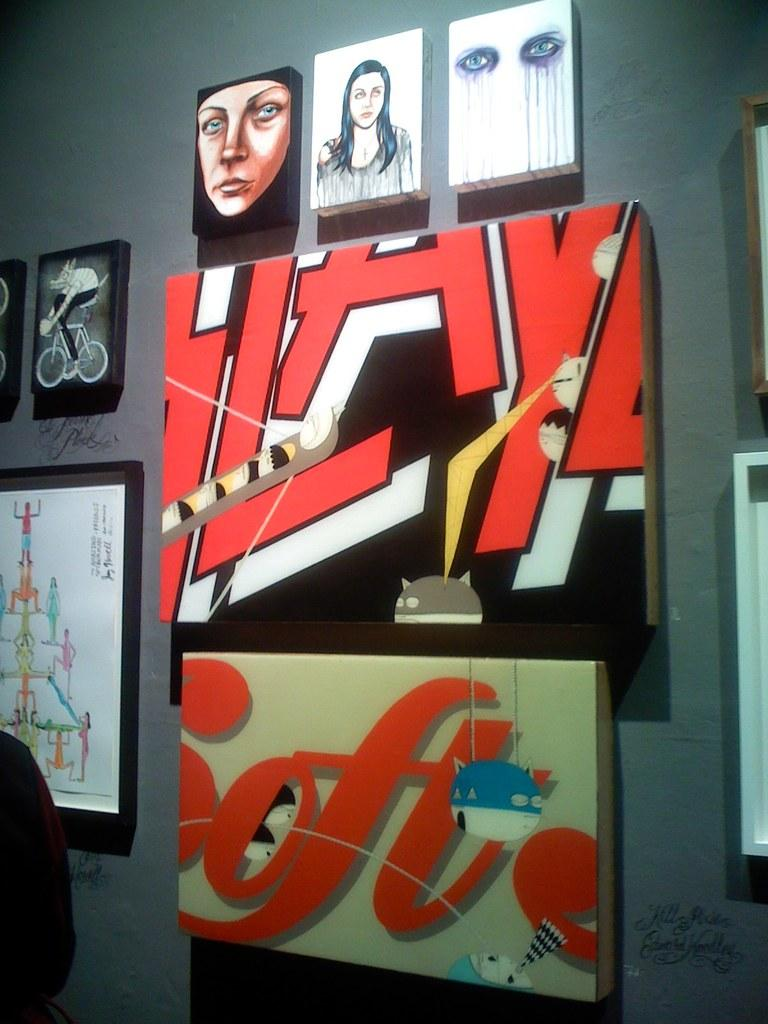What is present on the wall in the image? There are photo frames and paintings on the wall. Are there any other objects attached to the wall? Yes, there are two boards attached to the wall. Is there any rain visible in the image? No, there is no rain visible in the image. What type of cast can be seen on the wall in the image? There is no cast present on the wall in the image. 